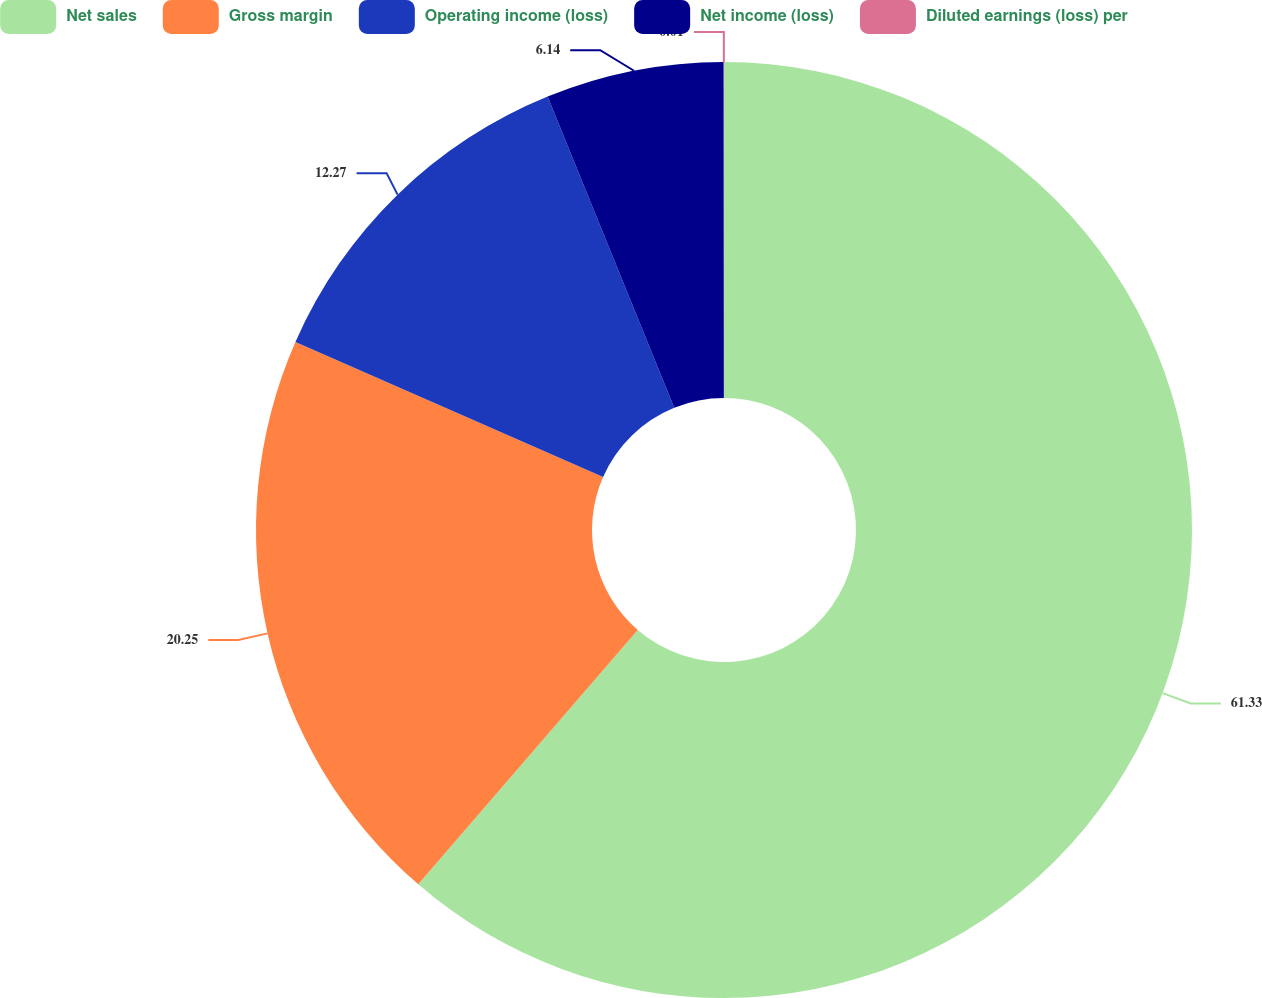<chart> <loc_0><loc_0><loc_500><loc_500><pie_chart><fcel>Net sales<fcel>Gross margin<fcel>Operating income (loss)<fcel>Net income (loss)<fcel>Diluted earnings (loss) per<nl><fcel>61.33%<fcel>20.25%<fcel>12.27%<fcel>6.14%<fcel>0.01%<nl></chart> 